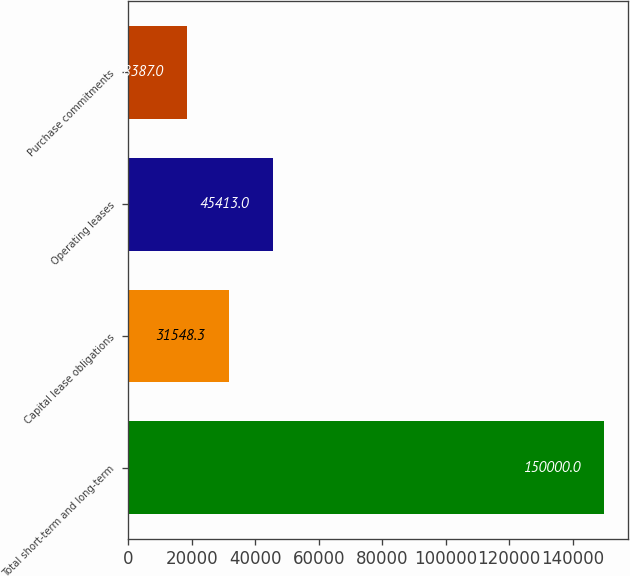Convert chart. <chart><loc_0><loc_0><loc_500><loc_500><bar_chart><fcel>Total short-term and long-term<fcel>Capital lease obligations<fcel>Operating leases<fcel>Purchase commitments<nl><fcel>150000<fcel>31548.3<fcel>45413<fcel>18387<nl></chart> 